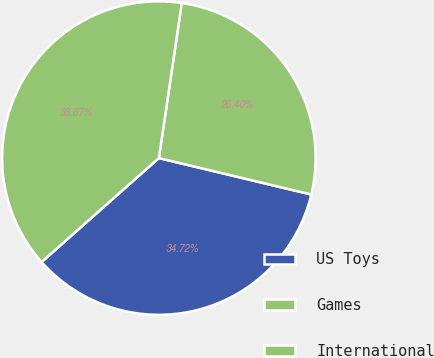Convert chart to OTSL. <chart><loc_0><loc_0><loc_500><loc_500><pie_chart><fcel>US Toys<fcel>Games<fcel>International<nl><fcel>34.72%<fcel>26.4%<fcel>38.87%<nl></chart> 